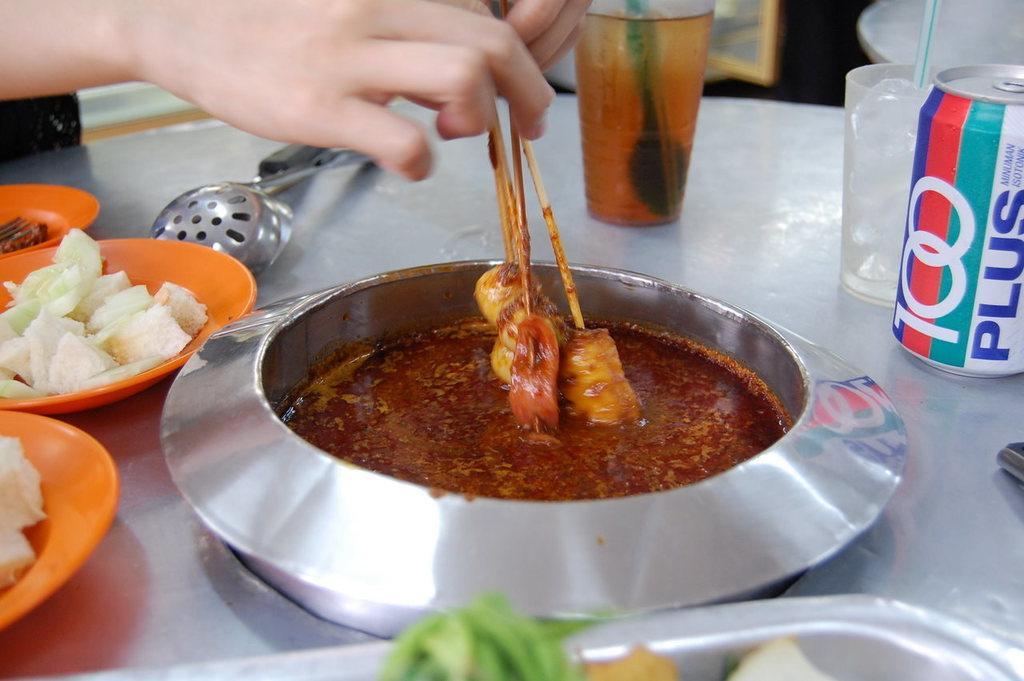Describe this image in one or two sentences. In this image we can see a person holding skewers, serving plates with food in them, ladles, glass tumblers and a beverage tin. 